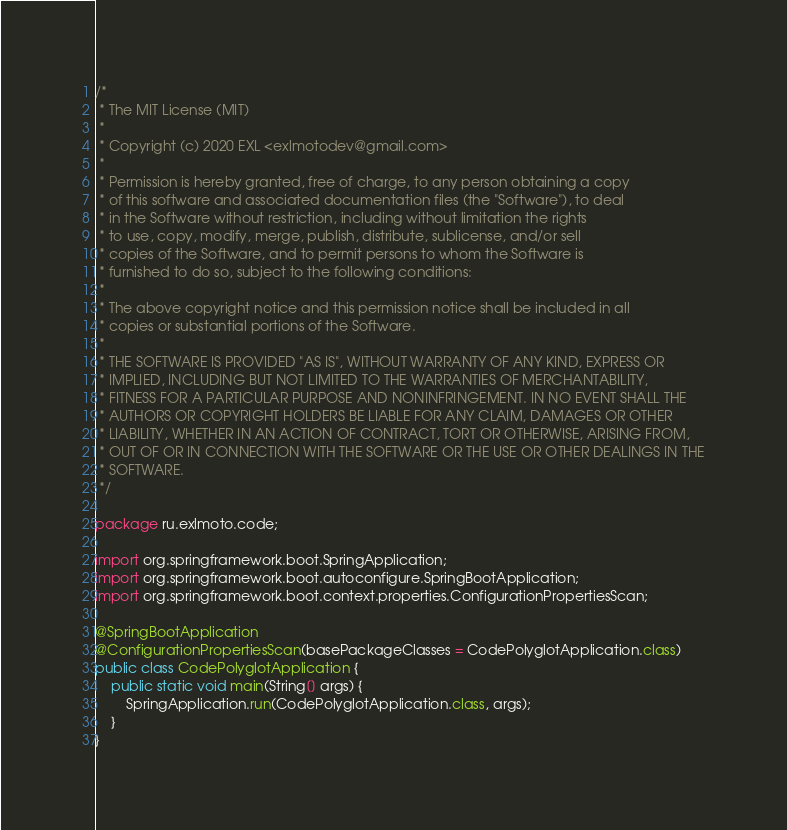<code> <loc_0><loc_0><loc_500><loc_500><_Java_>/*
 * The MIT License (MIT)
 *
 * Copyright (c) 2020 EXL <exlmotodev@gmail.com>
 *
 * Permission is hereby granted, free of charge, to any person obtaining a copy
 * of this software and associated documentation files (the "Software"), to deal
 * in the Software without restriction, including without limitation the rights
 * to use, copy, modify, merge, publish, distribute, sublicense, and/or sell
 * copies of the Software, and to permit persons to whom the Software is
 * furnished to do so, subject to the following conditions:
 *
 * The above copyright notice and this permission notice shall be included in all
 * copies or substantial portions of the Software.
 *
 * THE SOFTWARE IS PROVIDED "AS IS", WITHOUT WARRANTY OF ANY KIND, EXPRESS OR
 * IMPLIED, INCLUDING BUT NOT LIMITED TO THE WARRANTIES OF MERCHANTABILITY,
 * FITNESS FOR A PARTICULAR PURPOSE AND NONINFRINGEMENT. IN NO EVENT SHALL THE
 * AUTHORS OR COPYRIGHT HOLDERS BE LIABLE FOR ANY CLAIM, DAMAGES OR OTHER
 * LIABILITY, WHETHER IN AN ACTION OF CONTRACT, TORT OR OTHERWISE, ARISING FROM,
 * OUT OF OR IN CONNECTION WITH THE SOFTWARE OR THE USE OR OTHER DEALINGS IN THE
 * SOFTWARE.
 */

package ru.exlmoto.code;

import org.springframework.boot.SpringApplication;
import org.springframework.boot.autoconfigure.SpringBootApplication;
import org.springframework.boot.context.properties.ConfigurationPropertiesScan;

@SpringBootApplication
@ConfigurationPropertiesScan(basePackageClasses = CodePolyglotApplication.class)
public class CodePolyglotApplication {
	public static void main(String[] args) {
		SpringApplication.run(CodePolyglotApplication.class, args);
	}
}
</code> 